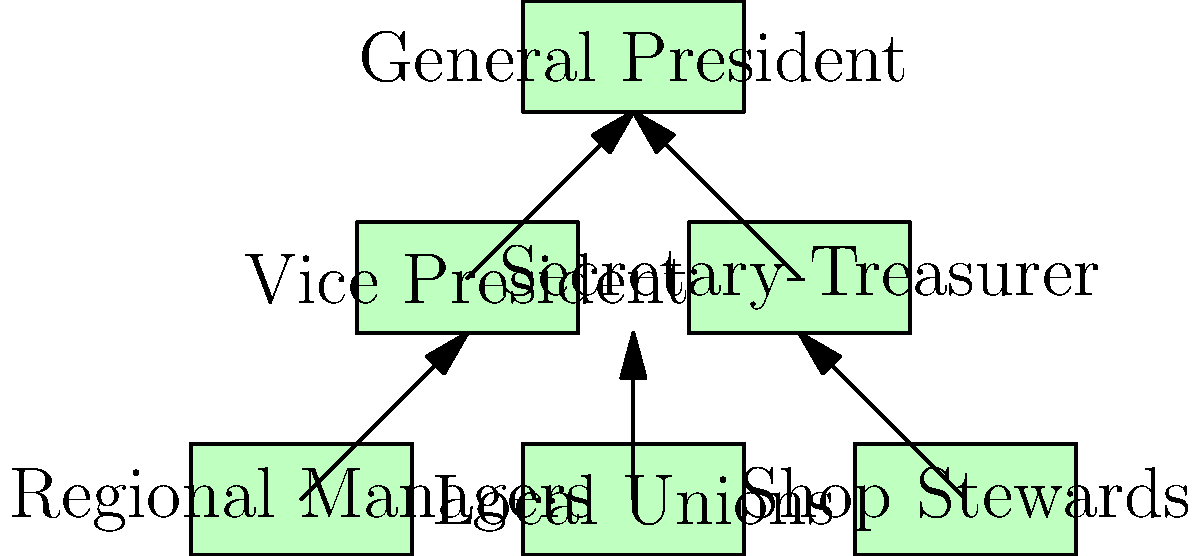In the organizational chart of the Teamsters Union, which position directly oversees the Local Unions and is responsible for the union's finances? To answer this question, let's analyze the organizational chart step-by-step:

1. At the top of the chart, we see the General President, who oversees the entire union.

2. Directly below the General President, there are two positions:
   a) Vice President
   b) Secretary-Treasurer

3. The Vice President's branch leads to the Regional Managers.

4. The Secretary-Treasurer's branch leads to two positions:
   a) Local Unions
   b) Shop Stewards

5. The Local Unions are positioned directly under the Secretary-Treasurer in the chart.

6. In union structures, the Secretary-Treasurer is typically responsible for managing the organization's finances.

Therefore, based on the organizational chart and general knowledge of union structures, the Secretary-Treasurer is the position that directly oversees the Local Unions and is responsible for the union's finances.
Answer: Secretary-Treasurer 